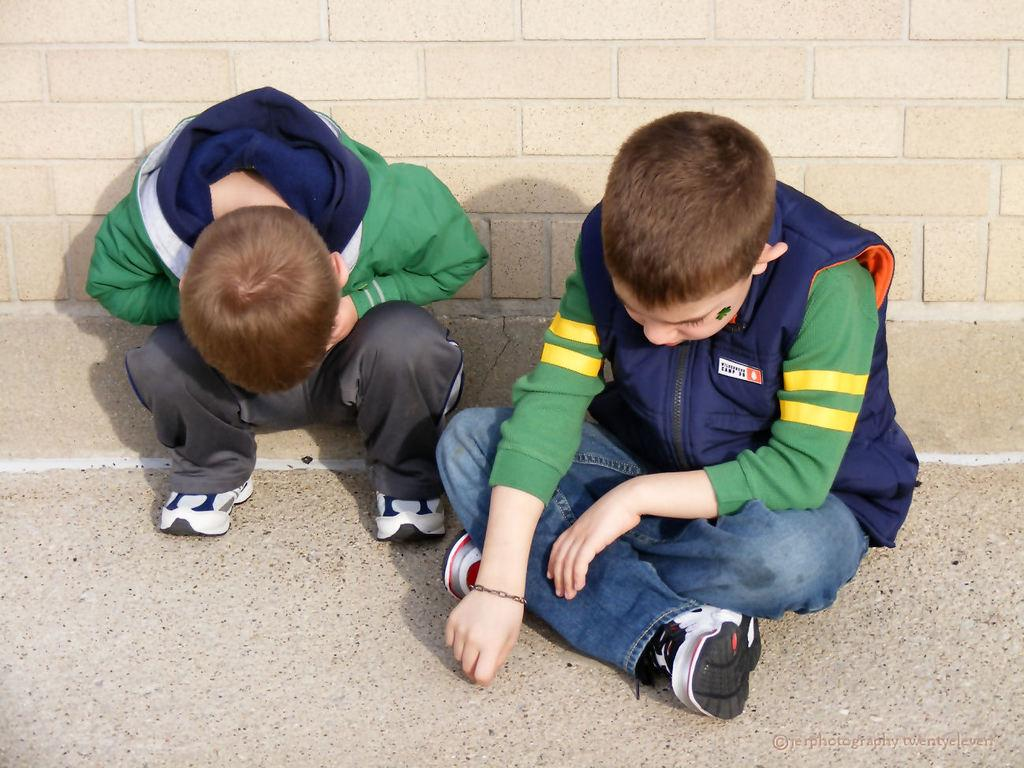How many people are in the image? There are two boys in the image. What are the boys doing in the image? The boys are sitting on the floor. What can be seen in the background of the image? There is a wall in the background of the image. Where is the text located in the image? The text is at the bottom right of the image. What type of feather can be seen on the wall in the image? There is no feather present on the wall in the image. How does the nerve affect the boys' behavior in the image? There is no mention of a nerve or any behavioral effects in the image. 